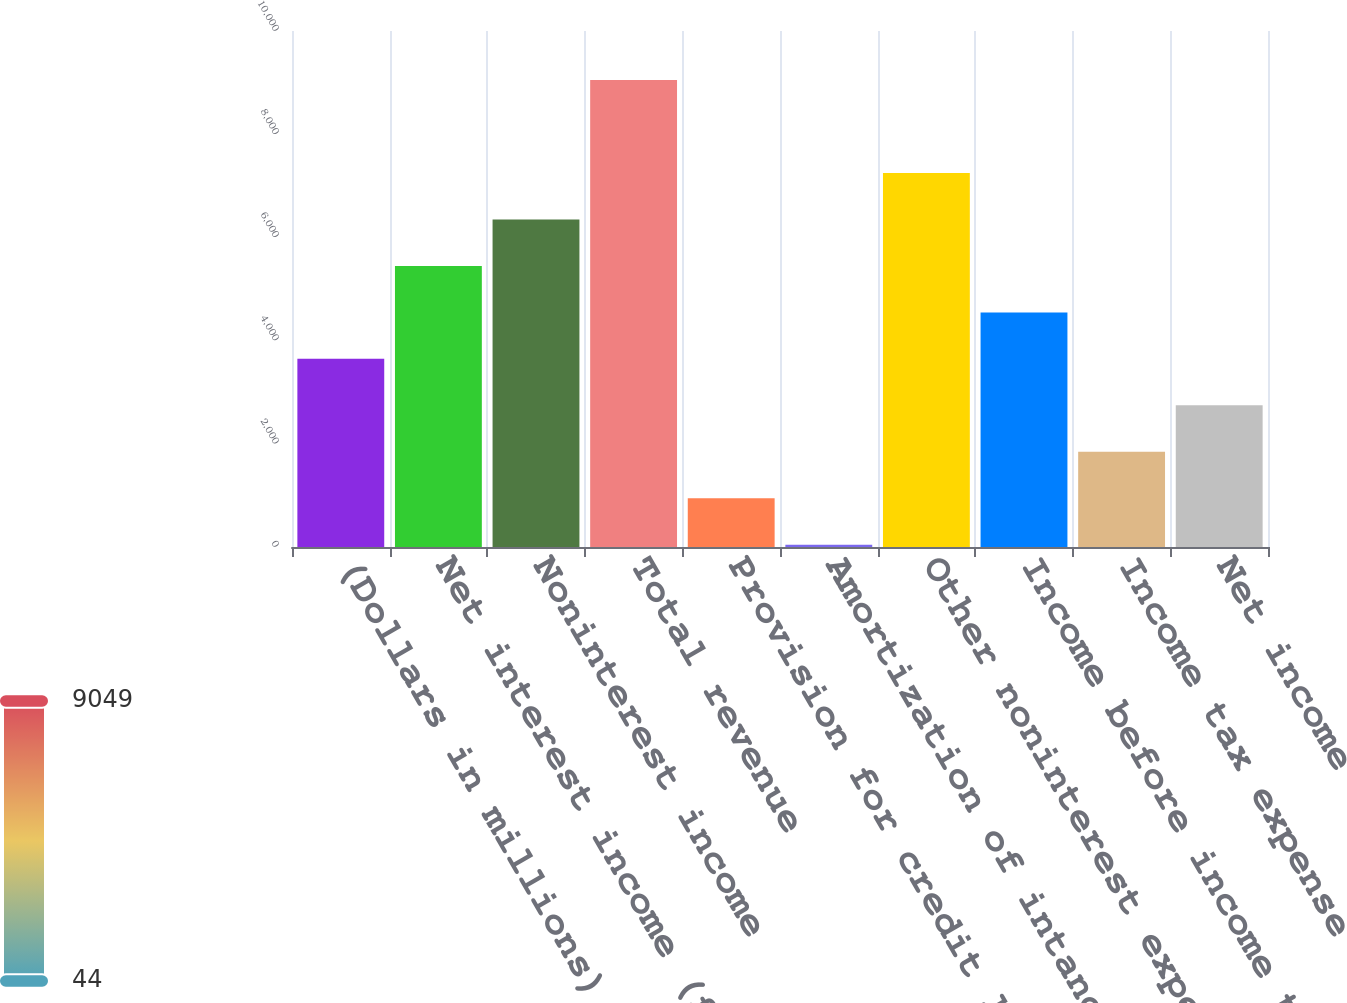Convert chart. <chart><loc_0><loc_0><loc_500><loc_500><bar_chart><fcel>(Dollars in millions)<fcel>Net interest income (fully<fcel>Noninterest income<fcel>Total revenue<fcel>Provision for credit losses<fcel>Amortization of intangibles<fcel>Other noninterest expense<fcel>Income before income taxes<fcel>Income tax expense<fcel>Net income<nl><fcel>3646<fcel>5447<fcel>6347.5<fcel>9049<fcel>944.5<fcel>44<fcel>7248<fcel>4546.5<fcel>1845<fcel>2745.5<nl></chart> 